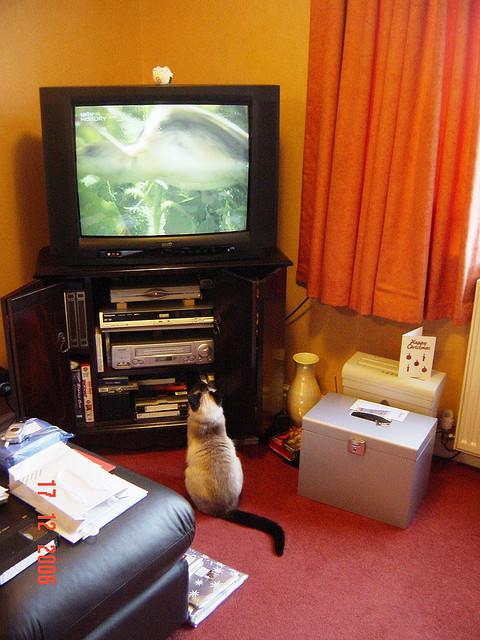What color is the cat's tail?
Be succinct. Black. Is the TV On?
Answer briefly. Yes. How many objects are sitting on the TV stand?
Give a very brief answer. 1. 